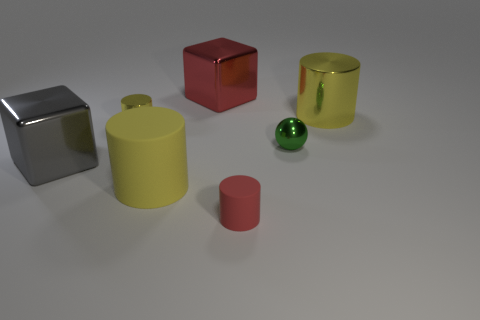Add 1 red rubber objects. How many objects exist? 8 Subtract all big rubber cylinders. How many cylinders are left? 3 Subtract 2 cylinders. How many cylinders are left? 2 Subtract all gray blocks. How many blocks are left? 1 Subtract all cubes. How many objects are left? 5 Subtract all brown blocks. Subtract all purple spheres. How many blocks are left? 2 Subtract all cyan spheres. How many red cylinders are left? 1 Subtract all small green shiny balls. Subtract all cyan matte cylinders. How many objects are left? 6 Add 3 big metal cubes. How many big metal cubes are left? 5 Add 2 gray metal cubes. How many gray metal cubes exist? 3 